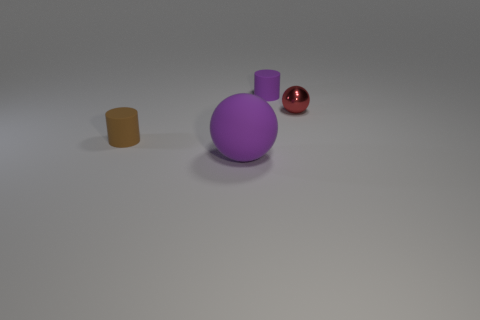Subtract 0 brown spheres. How many objects are left? 4 Subtract 1 spheres. How many spheres are left? 1 Subtract all red cylinders. Subtract all gray balls. How many cylinders are left? 2 Subtract all yellow balls. How many blue cylinders are left? 0 Subtract all gray metallic cylinders. Subtract all small purple cylinders. How many objects are left? 3 Add 4 small red things. How many small red things are left? 5 Add 1 big yellow metal spheres. How many big yellow metal spheres exist? 1 Add 4 purple things. How many objects exist? 8 